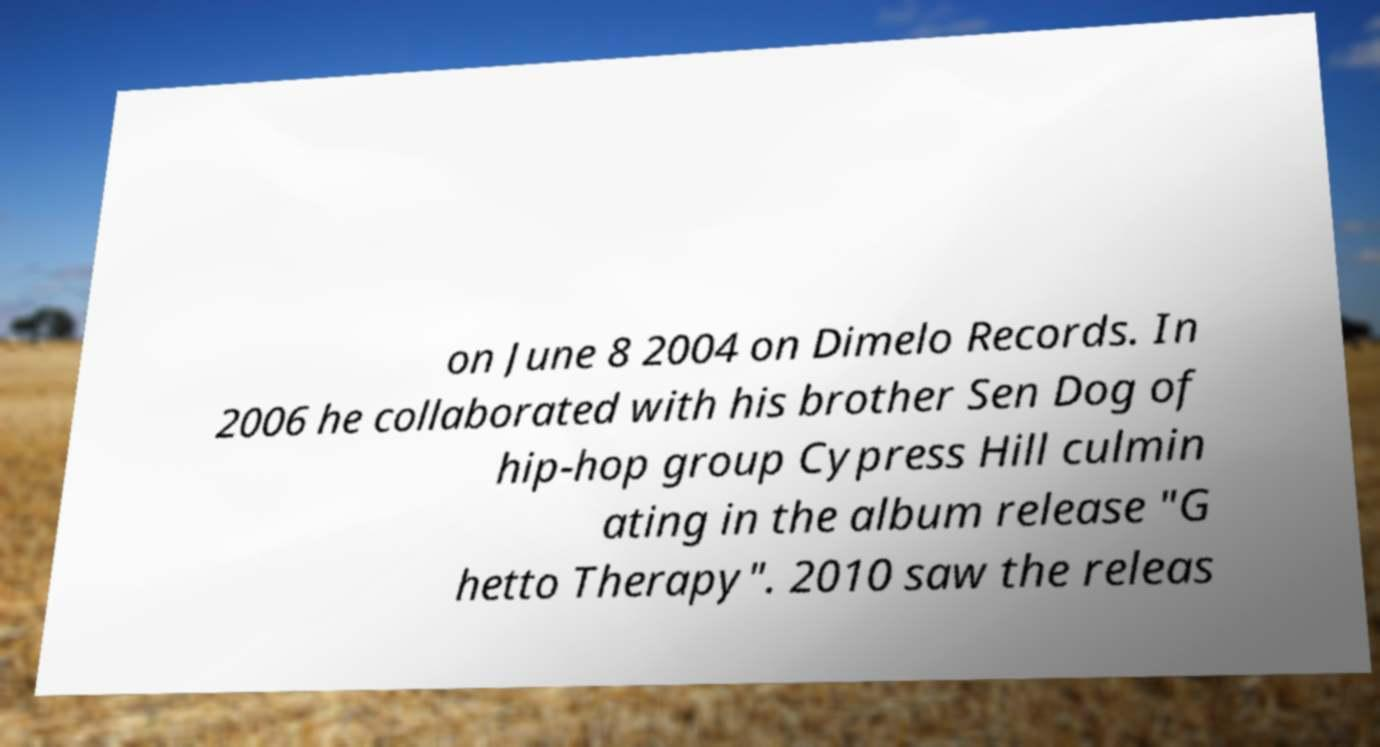Please read and relay the text visible in this image. What does it say? on June 8 2004 on Dimelo Records. In 2006 he collaborated with his brother Sen Dog of hip-hop group Cypress Hill culmin ating in the album release "G hetto Therapy". 2010 saw the releas 